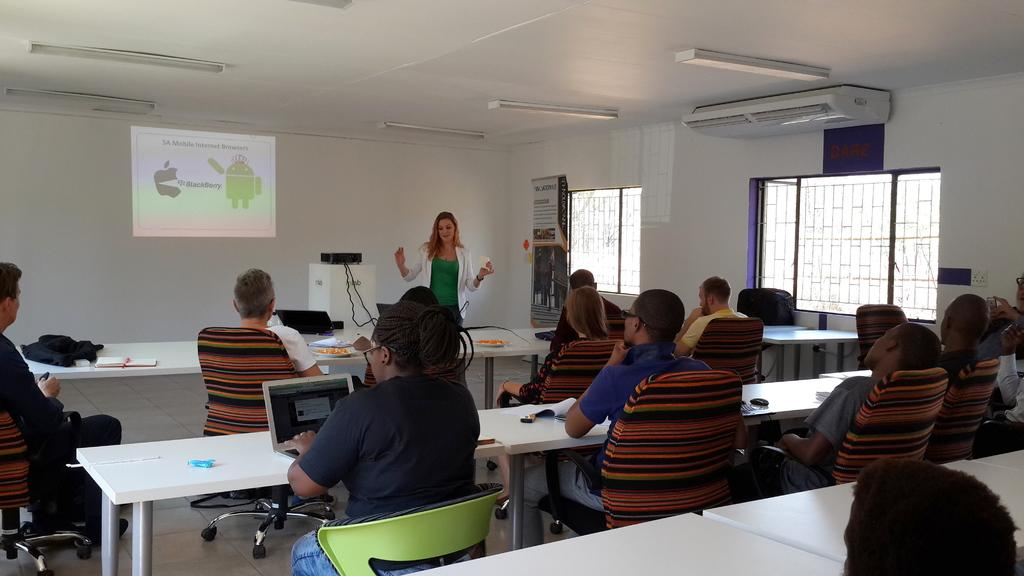What are the people in the image doing? The group of people is sitting in chairs. Where are the chairs located in relation to the table? The chairs are near a table. What can be seen in the background of the image? There is a hoarding, an air conditioner, a light, a screen, a projector, and a woman in the background. What shape is the goose that is flying over the table in the image? There is no goose present in the image; it only features a group of people sitting in chairs, a table, and various elements in the background. 